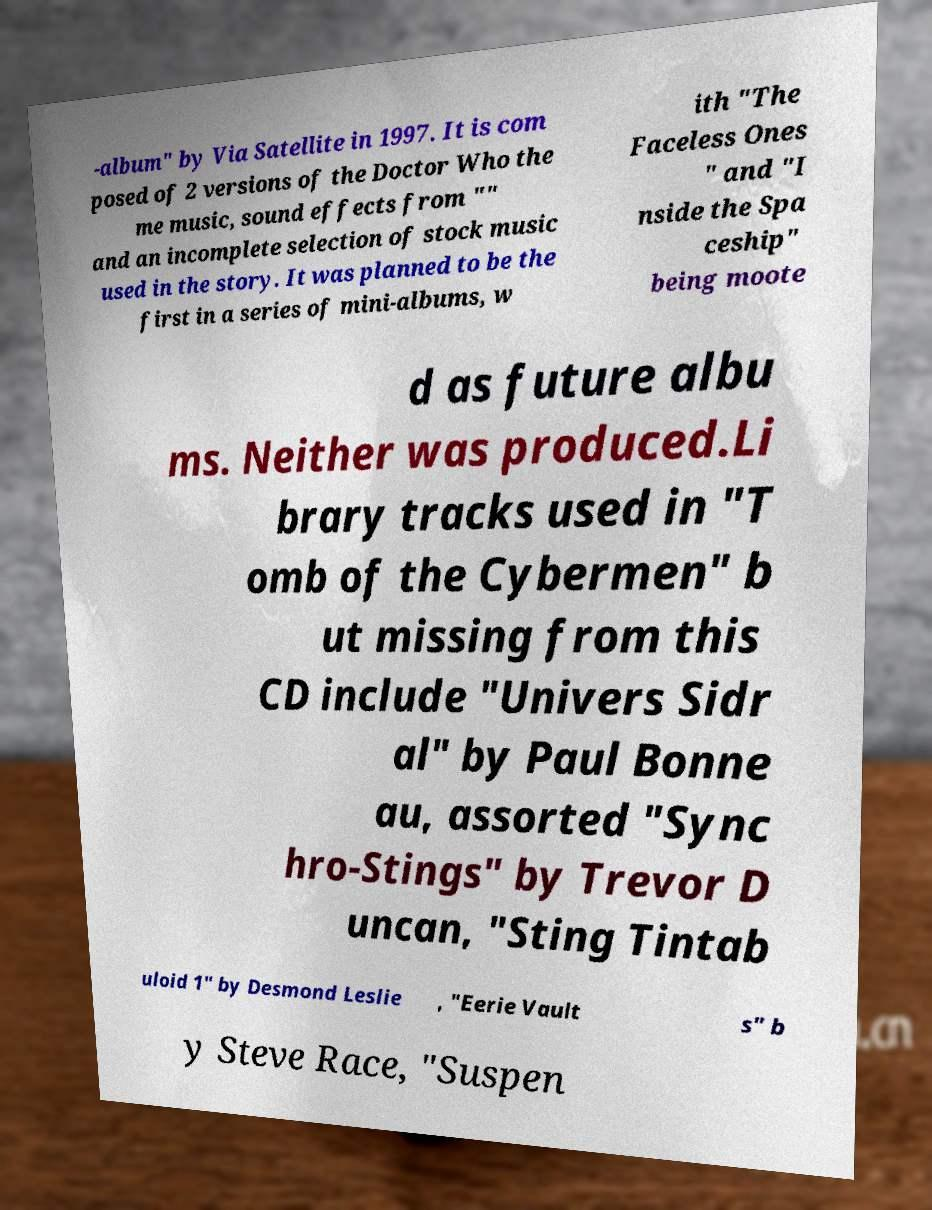Can you accurately transcribe the text from the provided image for me? -album" by Via Satellite in 1997. It is com posed of 2 versions of the Doctor Who the me music, sound effects from "" and an incomplete selection of stock music used in the story. It was planned to be the first in a series of mini-albums, w ith "The Faceless Ones " and "I nside the Spa ceship" being moote d as future albu ms. Neither was produced.Li brary tracks used in "T omb of the Cybermen" b ut missing from this CD include "Univers Sidr al" by Paul Bonne au, assorted "Sync hro-Stings" by Trevor D uncan, "Sting Tintab uloid 1" by Desmond Leslie , "Eerie Vault s" b y Steve Race, "Suspen 